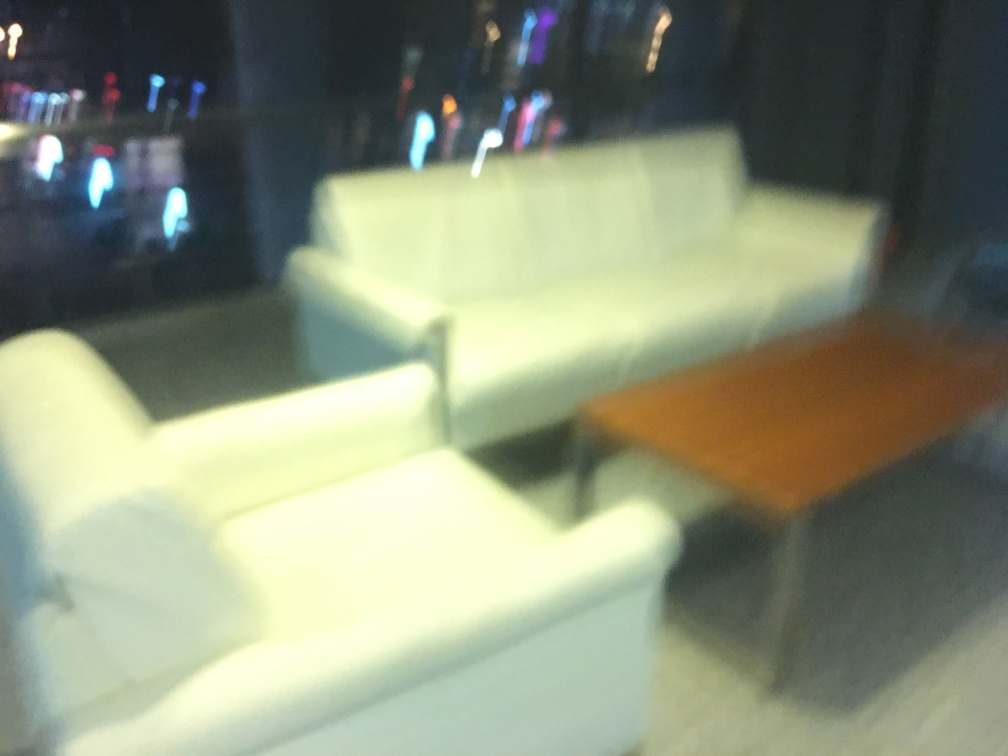Is the overall sharpness of the photo very poor? The sharpness of the photo is indeed poor. The image is noticeably blurry, lacking in clear edges and fine details which suggests either motion blur or a focus issue at the time of capture. It may also be a consequence of low lighting conditions or a low-quality camera sensor. 